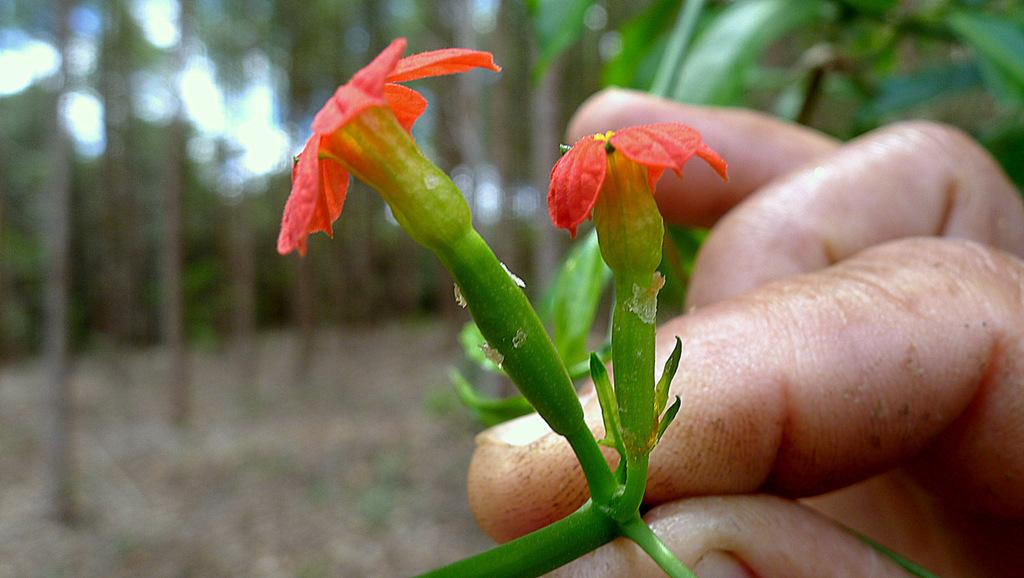What is the main subject in the center of the image? There is a person in the center of the image holding flowers. What can be seen in the background of the image? Trees are visible in the background of the image. What is visible at the bottom of the image? The ground is visible at the bottom of the image. What type of iron is being used by the person in the image? There is no iron present in the image; the person is holding flowers. What is the middle of the image made of? The middle of the image is not a physical object, so it cannot be made of any material. 